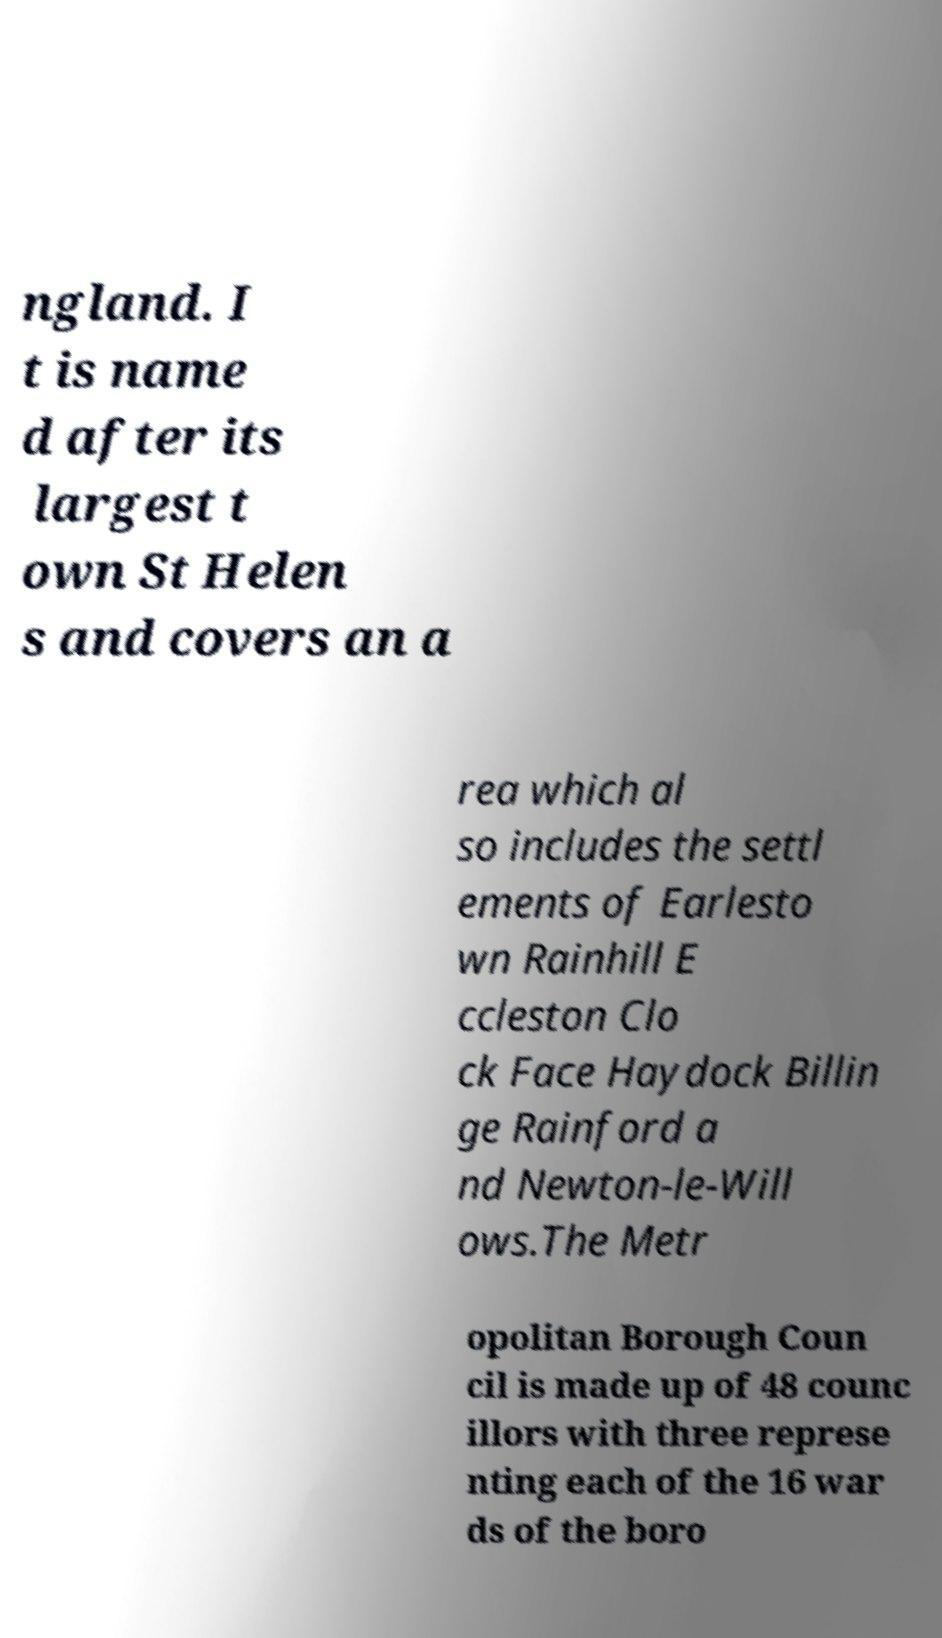What messages or text are displayed in this image? I need them in a readable, typed format. ngland. I t is name d after its largest t own St Helen s and covers an a rea which al so includes the settl ements of Earlesto wn Rainhill E ccleston Clo ck Face Haydock Billin ge Rainford a nd Newton-le-Will ows.The Metr opolitan Borough Coun cil is made up of 48 counc illors with three represe nting each of the 16 war ds of the boro 